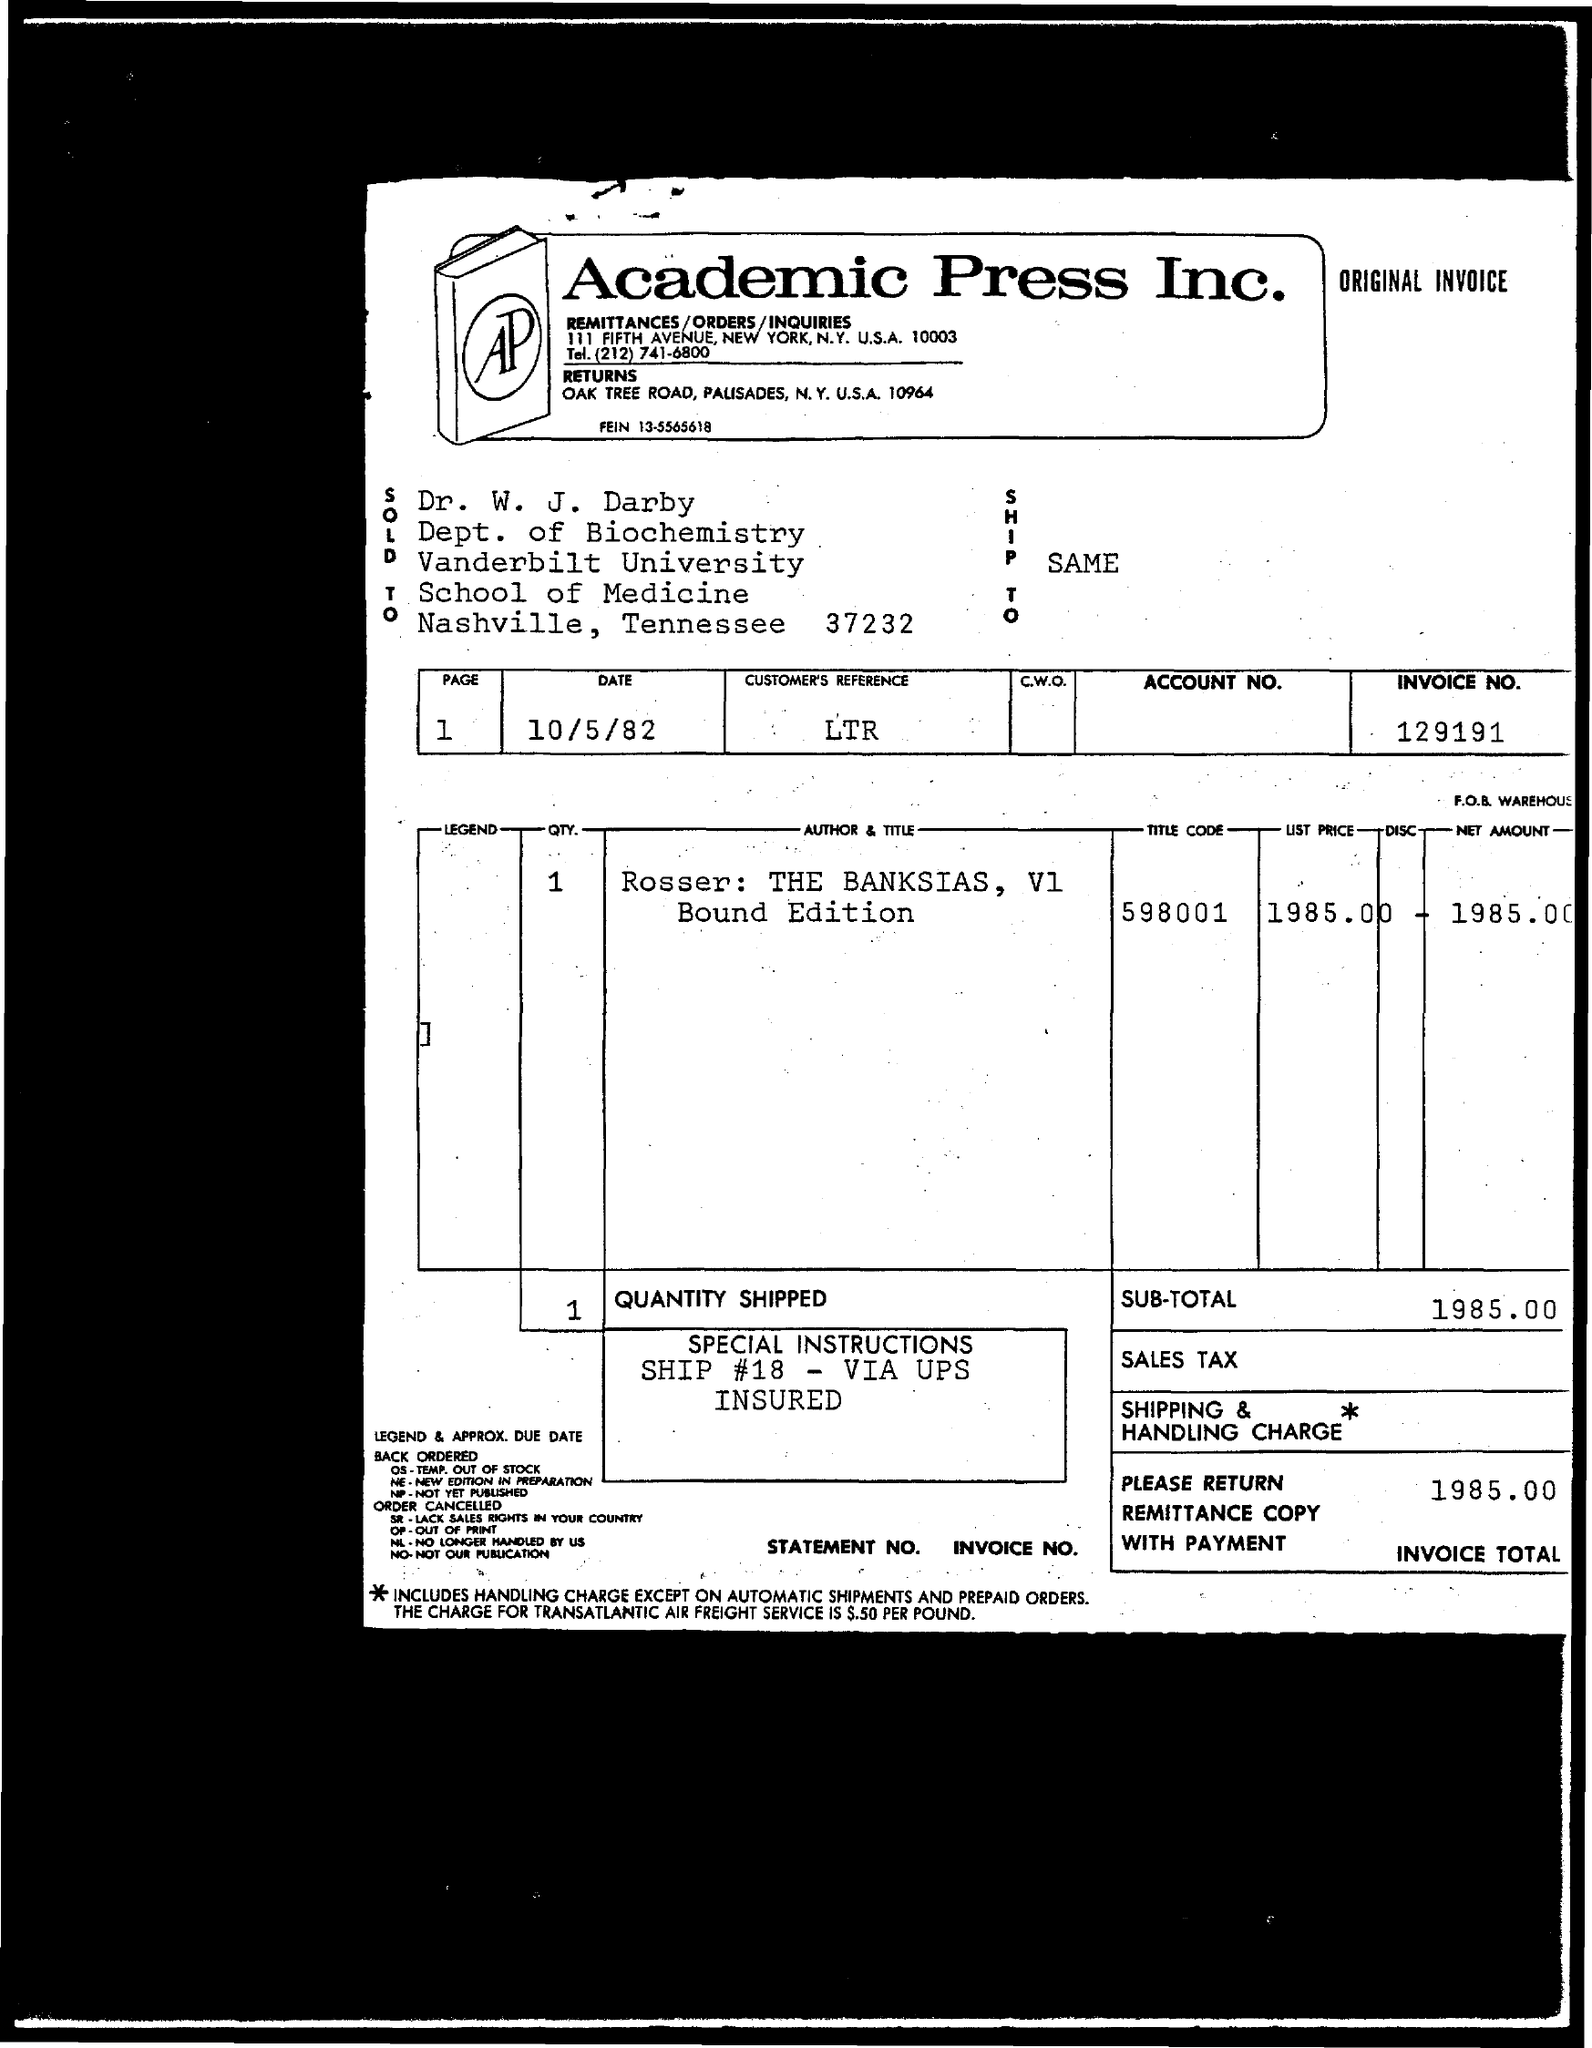Outline some significant characteristics in this image. The invoice number provided in the document is 129191... Can you please provide the customer's reference number as mentioned on the invoice? LTR... The net amount given in the invoice is 1985. The title code of the item mentioned in the invoice is 598001... The payee's name on the invoice is "Dr. W. J. Darby. 